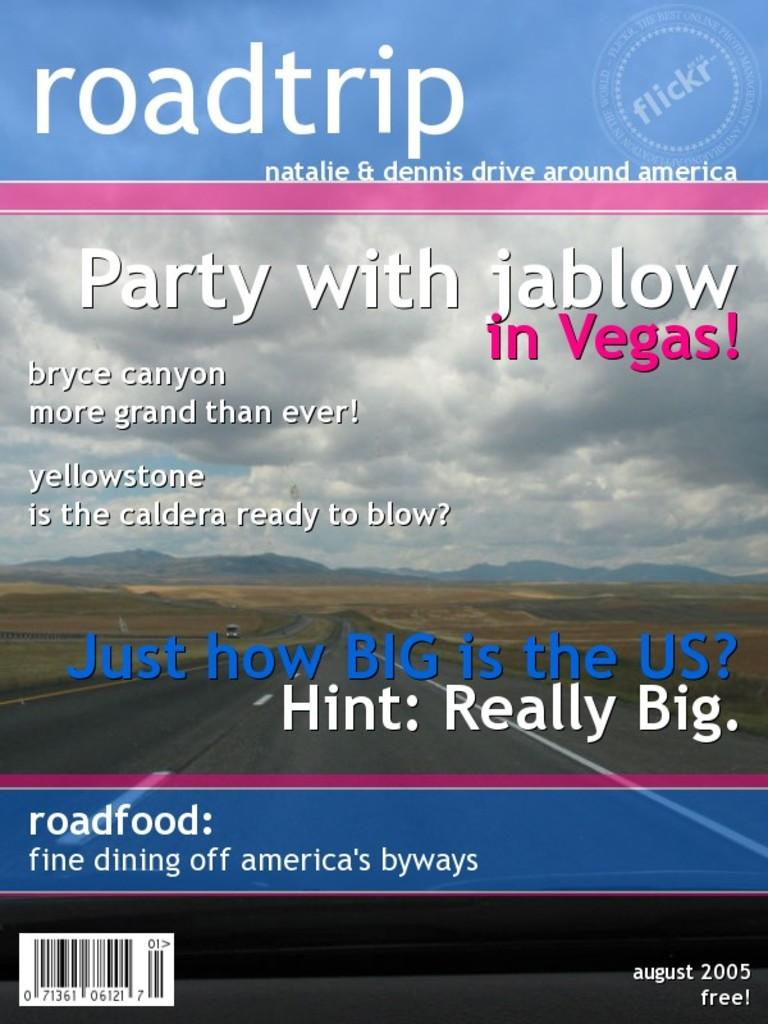Provide a one-sentence caption for the provided image. The free August 2005 edition of Roadtrip magazine featuring Natalie & Dennis who drive around America. 